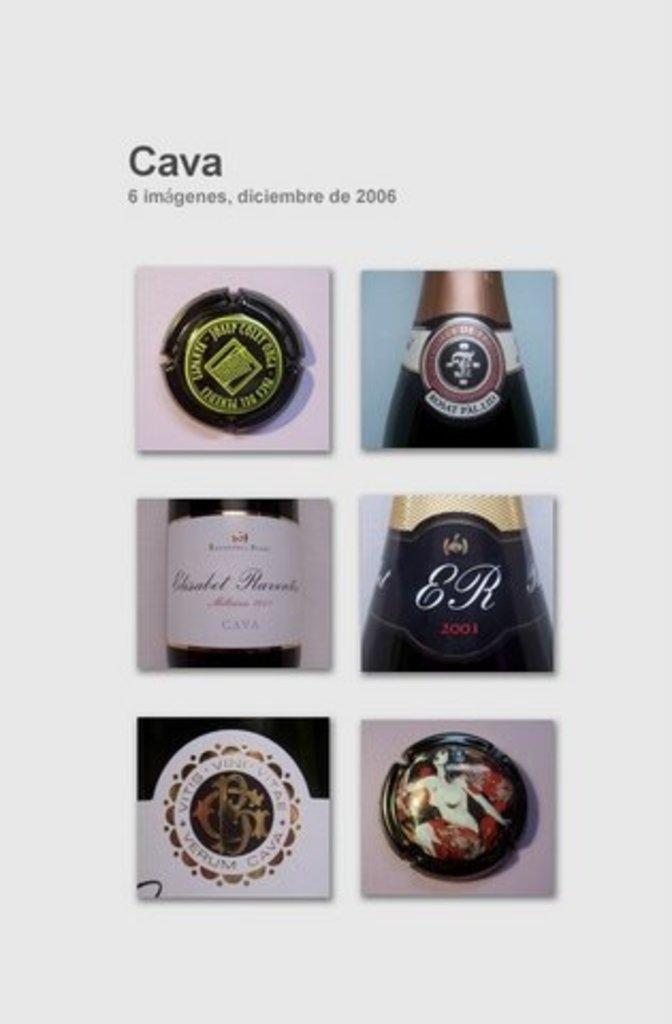Provide a one-sentence caption for the provided image. Collage of photos for a wine bottle that says ER on it. 